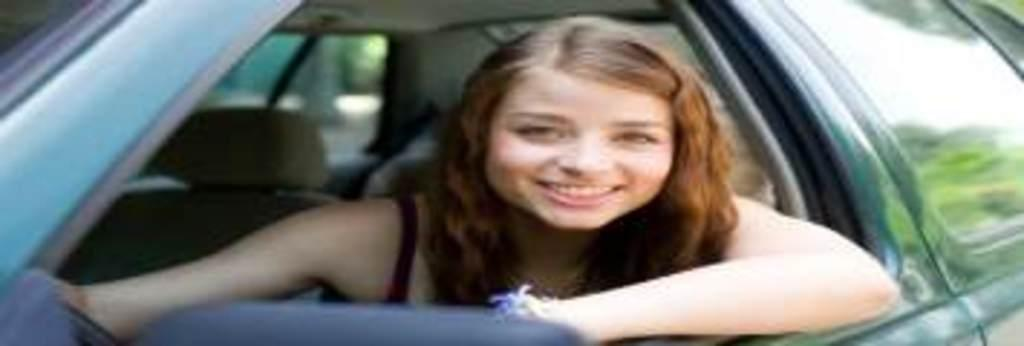Who is the main subject in the image? There is a woman in the image. What is the woman doing in the image? The woman is sitting on a car. Can you describe the car in the image? The car is blue. What else can be seen in the background of the image? There is a seat in the background of the image. What type of silver spoon is the woman holding in the image? There is no silver spoon present in the image. What scent can be detected from the woman in the image? There is no information about the scent of the woman in the image. 